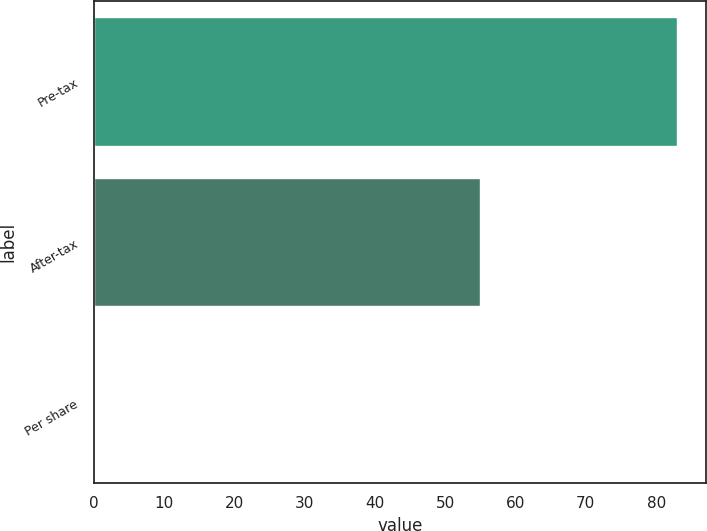<chart> <loc_0><loc_0><loc_500><loc_500><bar_chart><fcel>Pre-tax<fcel>After-tax<fcel>Per share<nl><fcel>83<fcel>55<fcel>0.03<nl></chart> 